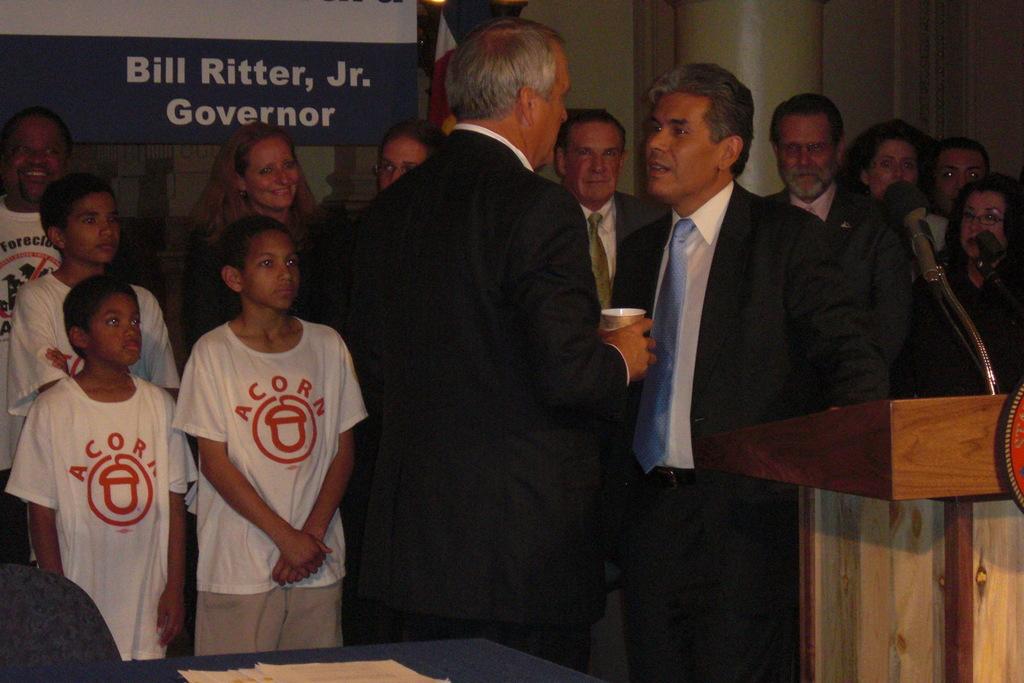Who is the governor?
Your answer should be compact. Bill ritter, jr. What organization are the front children representing?
Your answer should be compact. Acorn. 